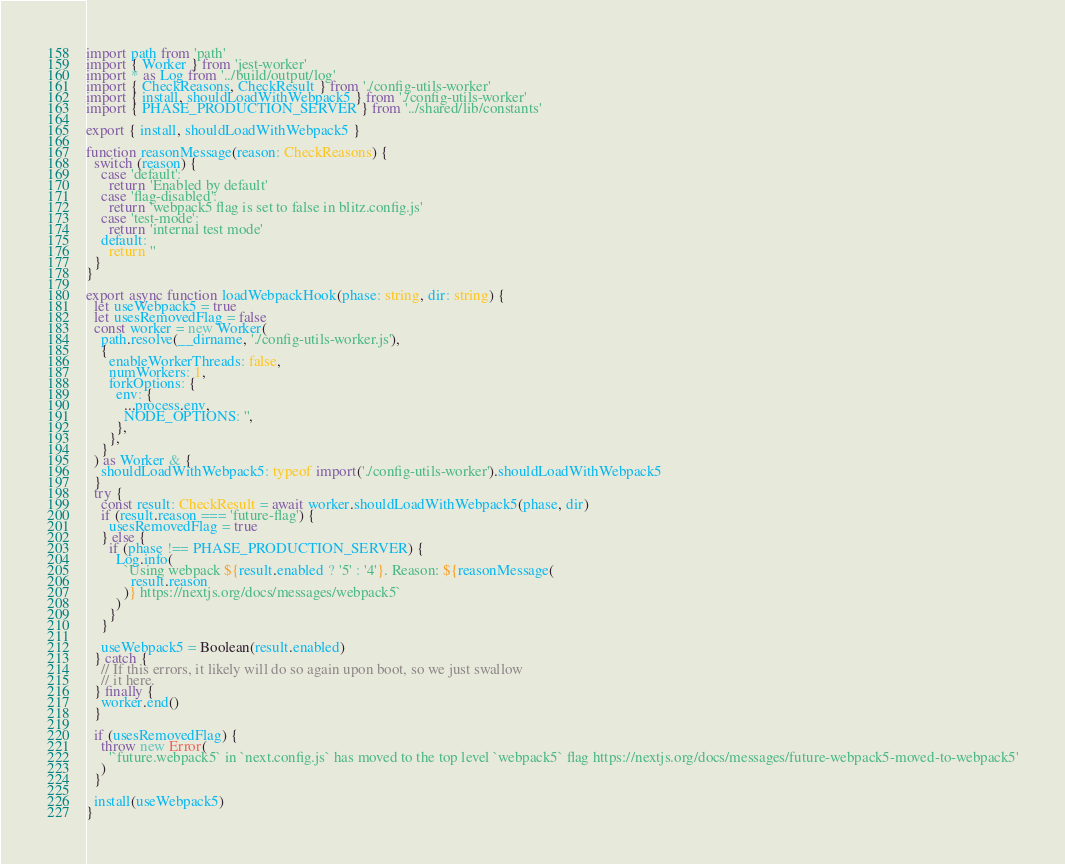Convert code to text. <code><loc_0><loc_0><loc_500><loc_500><_TypeScript_>import path from 'path'
import { Worker } from 'jest-worker'
import * as Log from '../build/output/log'
import { CheckReasons, CheckResult } from './config-utils-worker'
import { install, shouldLoadWithWebpack5 } from './config-utils-worker'
import { PHASE_PRODUCTION_SERVER } from '../shared/lib/constants'

export { install, shouldLoadWithWebpack5 }

function reasonMessage(reason: CheckReasons) {
  switch (reason) {
    case 'default':
      return 'Enabled by default'
    case 'flag-disabled':
      return 'webpack5 flag is set to false in blitz.config.js'
    case 'test-mode':
      return 'internal test mode'
    default:
      return ''
  }
}

export async function loadWebpackHook(phase: string, dir: string) {
  let useWebpack5 = true
  let usesRemovedFlag = false
  const worker = new Worker(
    path.resolve(__dirname, './config-utils-worker.js'),
    {
      enableWorkerThreads: false,
      numWorkers: 1,
      forkOptions: {
        env: {
          ...process.env,
          NODE_OPTIONS: '',
        },
      },
    }
  ) as Worker & {
    shouldLoadWithWebpack5: typeof import('./config-utils-worker').shouldLoadWithWebpack5
  }
  try {
    const result: CheckResult = await worker.shouldLoadWithWebpack5(phase, dir)
    if (result.reason === 'future-flag') {
      usesRemovedFlag = true
    } else {
      if (phase !== PHASE_PRODUCTION_SERVER) {
        Log.info(
          `Using webpack ${result.enabled ? '5' : '4'}. Reason: ${reasonMessage(
            result.reason
          )} https://nextjs.org/docs/messages/webpack5`
        )
      }
    }

    useWebpack5 = Boolean(result.enabled)
  } catch {
    // If this errors, it likely will do so again upon boot, so we just swallow
    // it here.
  } finally {
    worker.end()
  }

  if (usesRemovedFlag) {
    throw new Error(
      '`future.webpack5` in `next.config.js` has moved to the top level `webpack5` flag https://nextjs.org/docs/messages/future-webpack5-moved-to-webpack5'
    )
  }

  install(useWebpack5)
}
</code> 